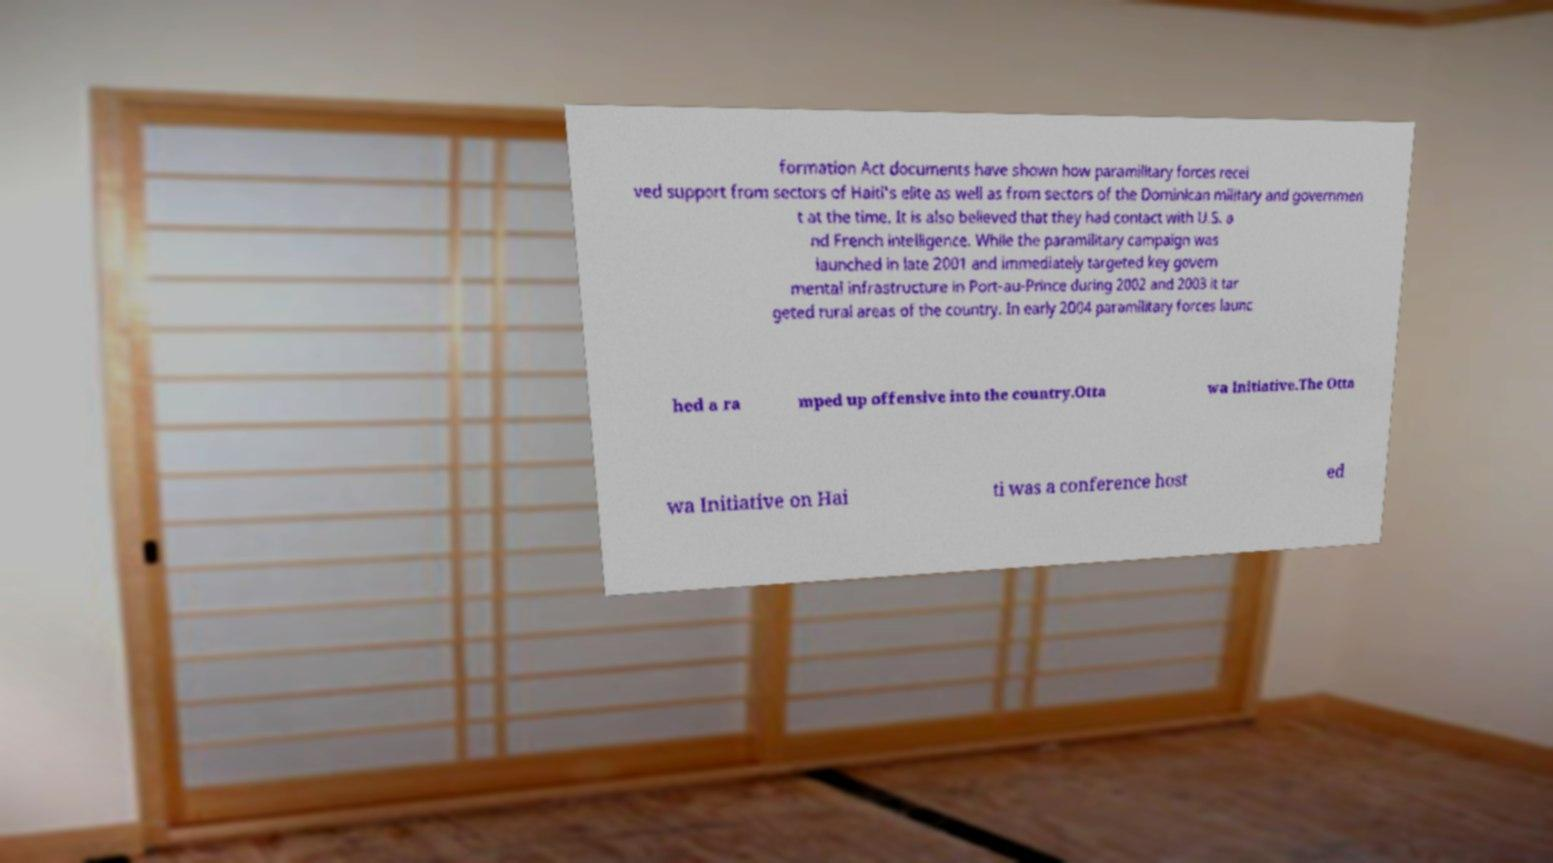I need the written content from this picture converted into text. Can you do that? formation Act documents have shown how paramilitary forces recei ved support from sectors of Haiti's elite as well as from sectors of the Dominican military and governmen t at the time. It is also believed that they had contact with U.S. a nd French intelligence. While the paramilitary campaign was launched in late 2001 and immediately targeted key govern mental infrastructure in Port-au-Prince during 2002 and 2003 it tar geted rural areas of the country. In early 2004 paramilitary forces launc hed a ra mped up offensive into the country.Otta wa Initiative.The Otta wa Initiative on Hai ti was a conference host ed 